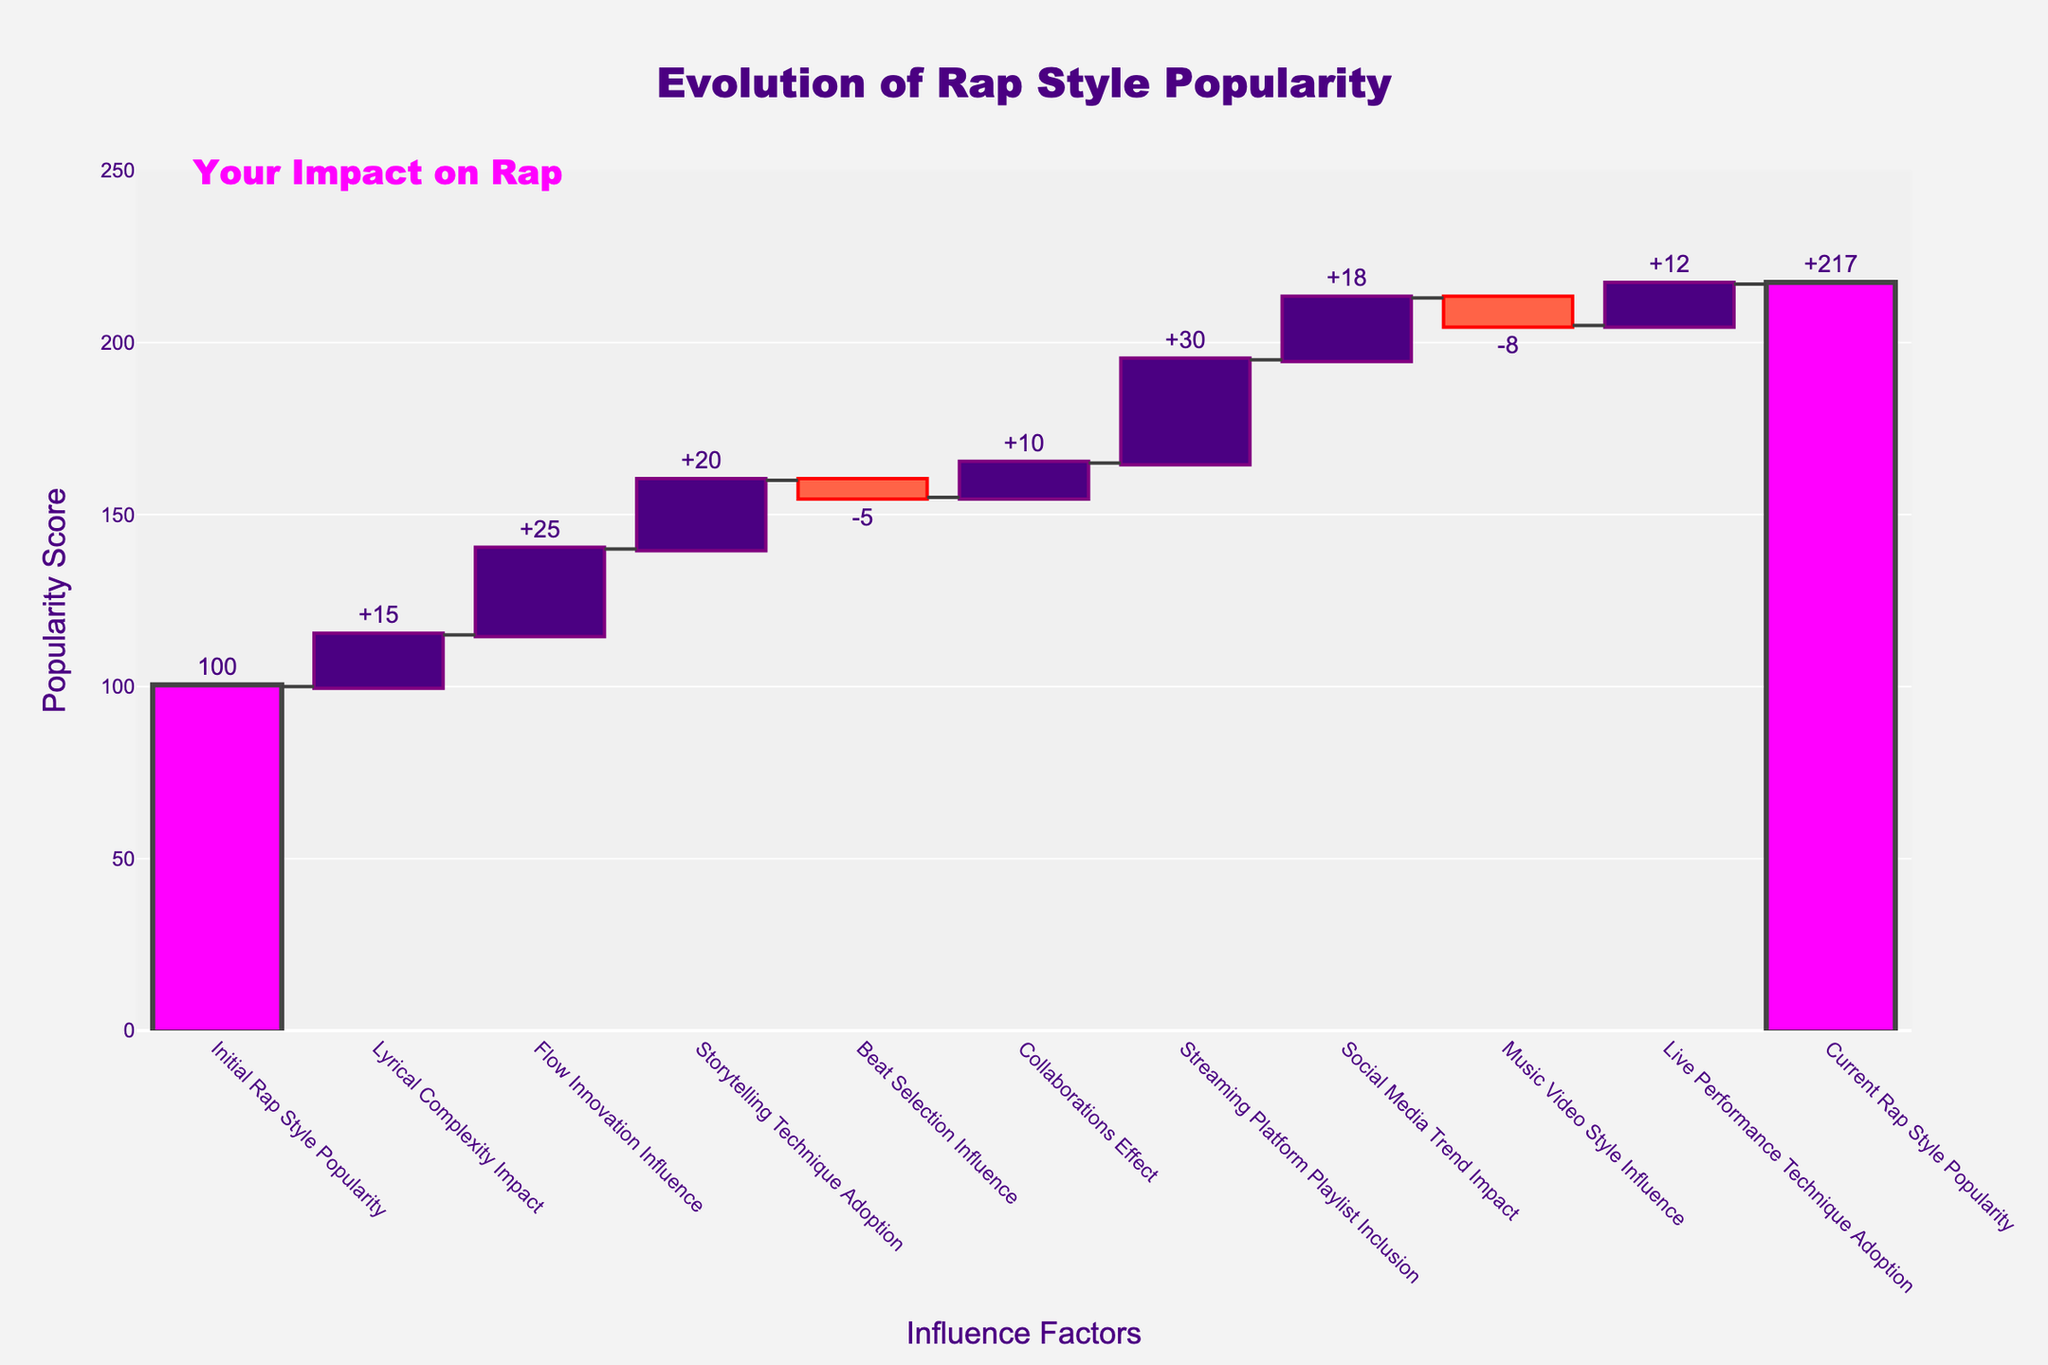What is the title of the figure? The title of the figure is found at the top center and reads "Evolution of Rap Style Popularity".
Answer: Evolution of Rap Style Popularity What is the value for Lyrical Complexity Impact? The value is indicated directly next to the "Lyrical Complexity Impact" bar on the chart, which is "+15".
Answer: +15 Which factor decreased rap style popularity the most? By looking at the negative values, "Music Video Style Influence" has the largest negative impact with a value of "-8".
Answer: Music Video Style Influence What was the initial popularity score of the rap style? The initial popularity is shown at the start of the chart and is "100".
Answer: 100 How much did the Streaming Platform Playlist Inclusion contribute to the change in rap style popularity? The value for "Streaming Platform Playlist Inclusion" is indicated directly next to its bar, which is "+30".
Answer: +30 What is the net effect of all positive influences on rap style popularity? Add the positive values: 15 (Lyrical Complexity) + 25 (Flow Innovation) + 20 (Storytelling) + 10 (Collaborations) + 30 (Streaming Platforms) + 18 (Social Media) + 12 (Live Performance) = 130.
Answer: 130 How much did the beat selection influence decrease the rap style popularity score? The value for "Beat Selection Influence" shows a negative impact, which is "-5".
Answer: -5 Which factor had a less positive impact compared to Lyrical Complexity Impact? By comparing the values of positive impacts, "Collaborations Effect" (+10) had a lesser effect than "Lyrical Complexity Impact" (+15).
Answer: Collaborations Effect What's the difference between the highest positive impact and the lowest negative impact? The highest positive impact is 30 (Streaming Platform) and the lowest negative impact is -8 (Music Video), the difference is 30 - (-8) = 38.
Answer: 38 Compare the initial and current rap style popularity scores. How much did it increase? Initial popularity is 100, and current popularity is 217, the increase is 217 - 100 = 117.
Answer: 117 